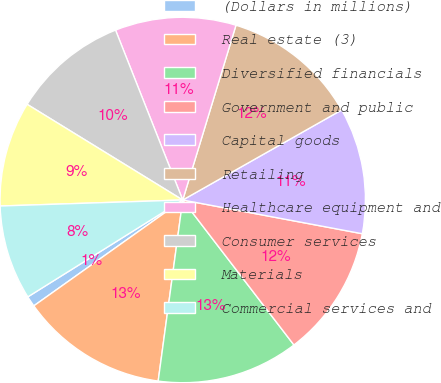Convert chart. <chart><loc_0><loc_0><loc_500><loc_500><pie_chart><fcel>(Dollars in millions)<fcel>Real estate (3)<fcel>Diversified financials<fcel>Government and public<fcel>Capital goods<fcel>Retailing<fcel>Healthcare equipment and<fcel>Consumer services<fcel>Materials<fcel>Commercial services and<nl><fcel>0.94%<fcel>13.02%<fcel>12.56%<fcel>11.63%<fcel>11.16%<fcel>12.09%<fcel>10.7%<fcel>10.23%<fcel>9.3%<fcel>8.37%<nl></chart> 